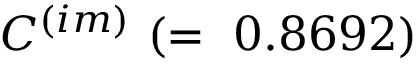<formula> <loc_0><loc_0><loc_500><loc_500>C ^ { ( i m ) } ( = 0 . 8 6 9 2 )</formula> 